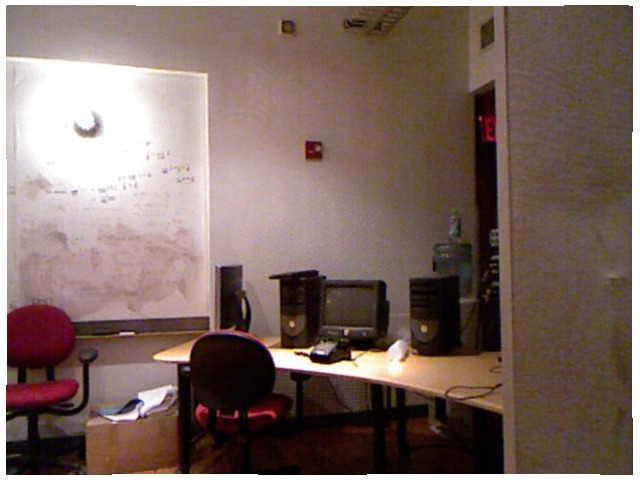<image>
Can you confirm if the chair is in front of the table? No. The chair is not in front of the table. The spatial positioning shows a different relationship between these objects. Where is the red chair in relation to the computer tower? Is it in front of the computer tower? No. The red chair is not in front of the computer tower. The spatial positioning shows a different relationship between these objects. Is the chair behind the table? No. The chair is not behind the table. From this viewpoint, the chair appears to be positioned elsewhere in the scene. 